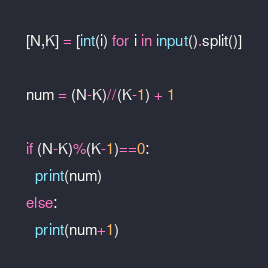Convert code to text. <code><loc_0><loc_0><loc_500><loc_500><_Python_>[N,K] = [int(i) for i in input().split()]

num = (N-K)//(K-1) + 1

if (N-K)%(K-1)==0:
  print(num)
else:
  print(num+1)
</code> 